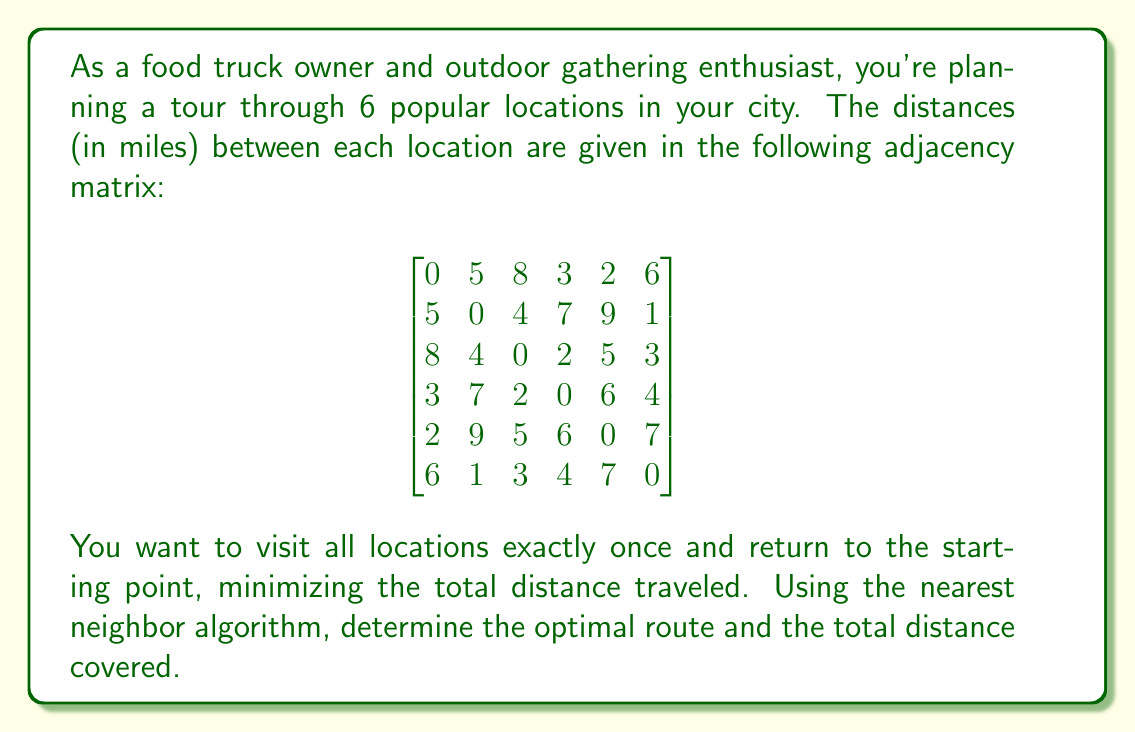Can you solve this math problem? To solve this problem, we'll use the nearest neighbor algorithm, which is a greedy approach to solve the Traveling Salesman Problem (TSP). Here's how we'll proceed:

1) Start at any arbitrary location. Let's choose location 1.

2) Find the nearest unvisited location and move to it.

3) Repeat step 2 until all locations have been visited.

4) Return to the starting location.

Let's apply the algorithm:

Step 1: Start at location 1.
Route: 1

Step 2: From location 1, the nearest unvisited location is 5 (distance 2).
Route: 1 → 5

Step 3: From location 5, the nearest unvisited location is 3 (distance 5).
Route: 1 → 5 → 3

Step 4: From location 3, the nearest unvisited location is 4 (distance 2).
Route: 1 → 5 → 3 → 4

Step 5: From location 4, the nearest unvisited location is 6 (distance 4).
Route: 1 → 5 → 3 → 4 → 6

Step 6: The only unvisited location is 2, so we go there (distance 1 from 6).
Route: 1 → 5 → 3 → 4 → 6 → 2

Step 7: Return to the starting location 1 (distance 5 from 2).
Final route: 1 → 5 → 3 → 4 → 6 → 2 → 1

To calculate the total distance:
$$ \text{Total Distance} = 2 + 5 + 2 + 4 + 1 + 5 = 19 \text{ miles} $$

It's important to note that while the nearest neighbor algorithm often provides a good solution, it doesn't always guarantee the optimal solution for all TSP instances. However, it's efficient and usually produces a near-optimal route.
Answer: The optimal route using the nearest neighbor algorithm is 1 → 5 → 3 → 4 → 6 → 2 → 1, with a total distance of 19 miles. 